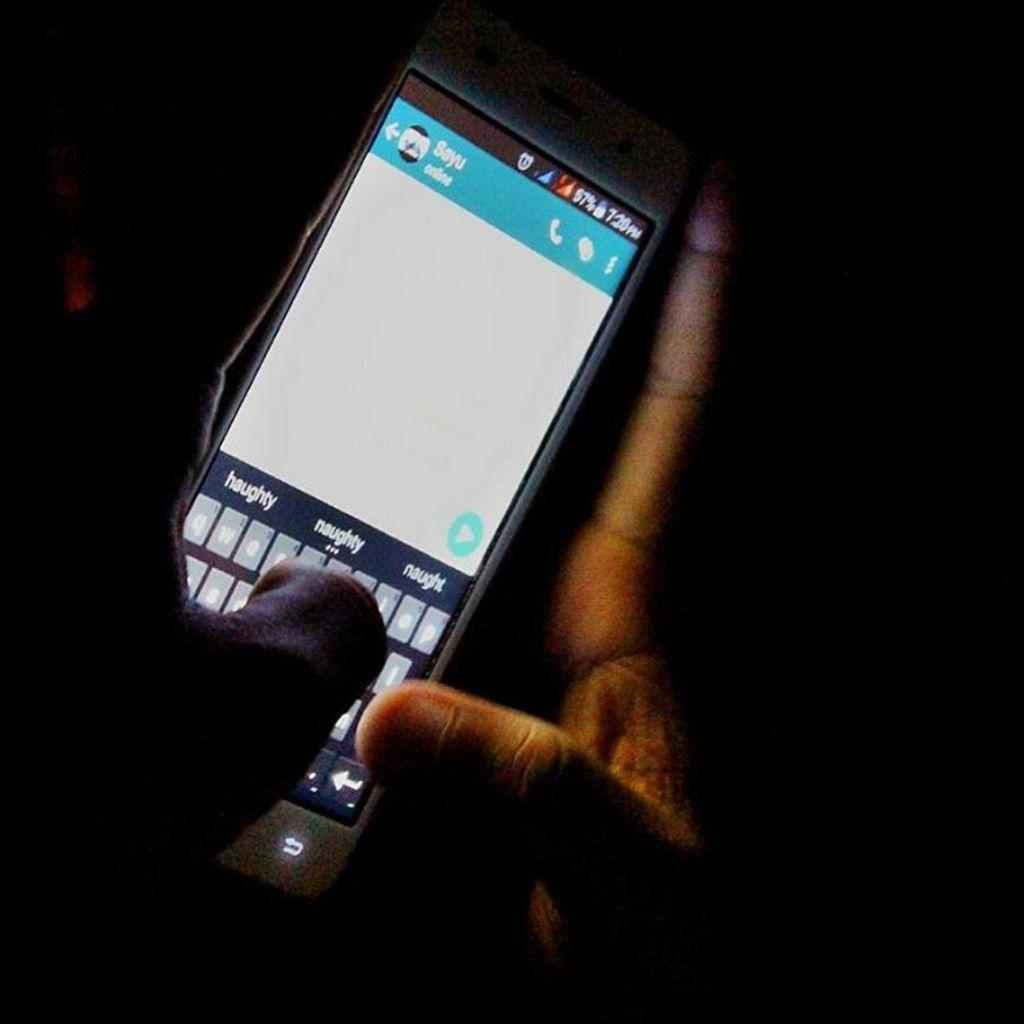Provide a one-sentence caption for the provided image. Darkly shadowed hands are texting on a smartphone that is displaying the suggested words haughty, naughty and naught. 